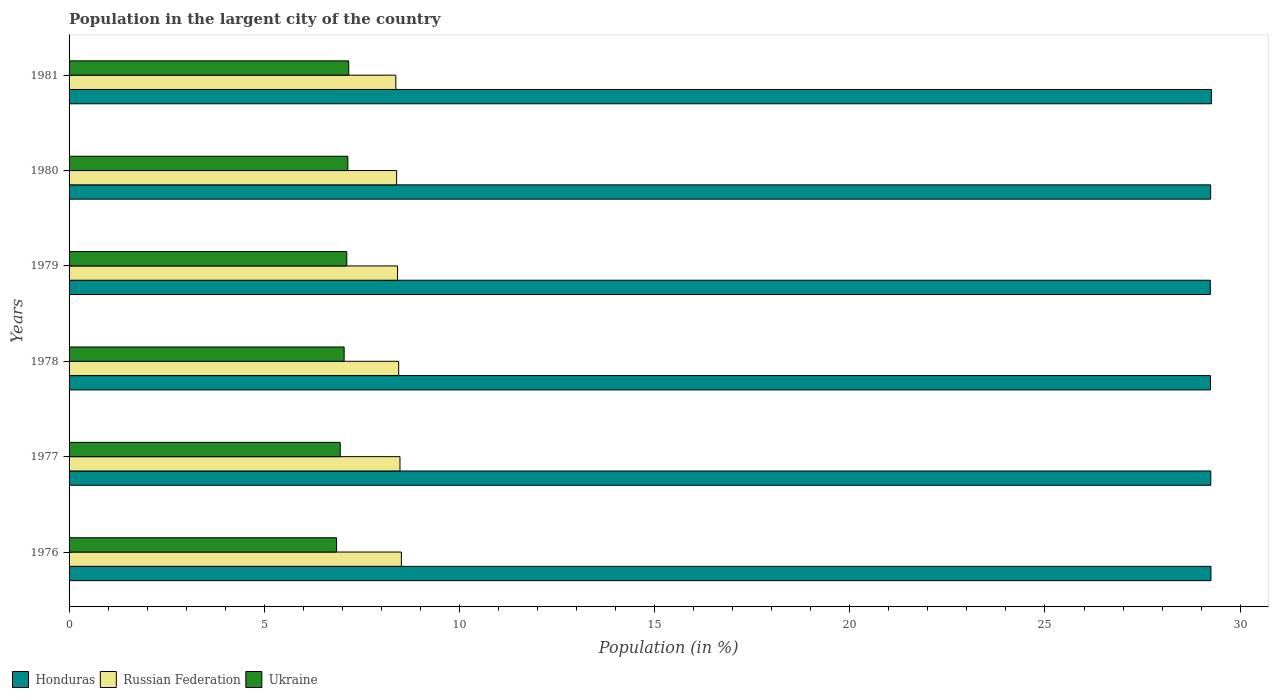Are the number of bars per tick equal to the number of legend labels?
Offer a terse response. Yes. In how many cases, is the number of bars for a given year not equal to the number of legend labels?
Your answer should be compact. 0. What is the percentage of population in the largent city in Honduras in 1976?
Keep it short and to the point. 29.25. Across all years, what is the maximum percentage of population in the largent city in Ukraine?
Ensure brevity in your answer.  7.16. Across all years, what is the minimum percentage of population in the largent city in Honduras?
Your answer should be compact. 29.24. In which year was the percentage of population in the largent city in Russian Federation maximum?
Make the answer very short. 1976. What is the total percentage of population in the largent city in Honduras in the graph?
Your answer should be very brief. 175.48. What is the difference between the percentage of population in the largent city in Russian Federation in 1976 and that in 1977?
Ensure brevity in your answer.  0.04. What is the difference between the percentage of population in the largent city in Honduras in 1981 and the percentage of population in the largent city in Ukraine in 1976?
Offer a terse response. 22.41. What is the average percentage of population in the largent city in Russian Federation per year?
Your answer should be very brief. 8.44. In the year 1979, what is the difference between the percentage of population in the largent city in Honduras and percentage of population in the largent city in Russian Federation?
Provide a succinct answer. 20.82. In how many years, is the percentage of population in the largent city in Ukraine greater than 13 %?
Make the answer very short. 0. What is the ratio of the percentage of population in the largent city in Ukraine in 1977 to that in 1978?
Your answer should be compact. 0.99. Is the percentage of population in the largent city in Ukraine in 1977 less than that in 1980?
Make the answer very short. Yes. Is the difference between the percentage of population in the largent city in Honduras in 1976 and 1979 greater than the difference between the percentage of population in the largent city in Russian Federation in 1976 and 1979?
Your response must be concise. No. What is the difference between the highest and the second highest percentage of population in the largent city in Honduras?
Your response must be concise. 0.01. What is the difference between the highest and the lowest percentage of population in the largent city in Ukraine?
Provide a short and direct response. 0.31. In how many years, is the percentage of population in the largent city in Russian Federation greater than the average percentage of population in the largent city in Russian Federation taken over all years?
Give a very brief answer. 3. Is the sum of the percentage of population in the largent city in Ukraine in 1976 and 1978 greater than the maximum percentage of population in the largent city in Honduras across all years?
Offer a terse response. No. What does the 3rd bar from the top in 1976 represents?
Your answer should be very brief. Honduras. What does the 2nd bar from the bottom in 1981 represents?
Make the answer very short. Russian Federation. How many years are there in the graph?
Give a very brief answer. 6. Does the graph contain any zero values?
Your answer should be compact. No. How are the legend labels stacked?
Your response must be concise. Horizontal. What is the title of the graph?
Provide a short and direct response. Population in the largent city of the country. Does "Low & middle income" appear as one of the legend labels in the graph?
Offer a very short reply. No. What is the label or title of the X-axis?
Offer a very short reply. Population (in %). What is the label or title of the Y-axis?
Give a very brief answer. Years. What is the Population (in %) of Honduras in 1976?
Your response must be concise. 29.25. What is the Population (in %) in Russian Federation in 1976?
Ensure brevity in your answer.  8.51. What is the Population (in %) of Ukraine in 1976?
Make the answer very short. 6.85. What is the Population (in %) in Honduras in 1977?
Offer a very short reply. 29.25. What is the Population (in %) in Russian Federation in 1977?
Provide a short and direct response. 8.48. What is the Population (in %) of Ukraine in 1977?
Provide a succinct answer. 6.95. What is the Population (in %) of Honduras in 1978?
Make the answer very short. 29.24. What is the Population (in %) of Russian Federation in 1978?
Provide a succinct answer. 8.44. What is the Population (in %) of Ukraine in 1978?
Make the answer very short. 7.05. What is the Population (in %) in Honduras in 1979?
Give a very brief answer. 29.24. What is the Population (in %) of Russian Federation in 1979?
Keep it short and to the point. 8.42. What is the Population (in %) of Ukraine in 1979?
Give a very brief answer. 7.11. What is the Population (in %) of Honduras in 1980?
Provide a short and direct response. 29.24. What is the Population (in %) in Russian Federation in 1980?
Keep it short and to the point. 8.39. What is the Population (in %) in Ukraine in 1980?
Your response must be concise. 7.14. What is the Population (in %) in Honduras in 1981?
Provide a short and direct response. 29.26. What is the Population (in %) of Russian Federation in 1981?
Provide a short and direct response. 8.37. What is the Population (in %) of Ukraine in 1981?
Keep it short and to the point. 7.16. Across all years, what is the maximum Population (in %) of Honduras?
Provide a short and direct response. 29.26. Across all years, what is the maximum Population (in %) in Russian Federation?
Offer a terse response. 8.51. Across all years, what is the maximum Population (in %) in Ukraine?
Provide a succinct answer. 7.16. Across all years, what is the minimum Population (in %) in Honduras?
Ensure brevity in your answer.  29.24. Across all years, what is the minimum Population (in %) in Russian Federation?
Make the answer very short. 8.37. Across all years, what is the minimum Population (in %) in Ukraine?
Provide a succinct answer. 6.85. What is the total Population (in %) of Honduras in the graph?
Offer a very short reply. 175.48. What is the total Population (in %) in Russian Federation in the graph?
Give a very brief answer. 50.61. What is the total Population (in %) of Ukraine in the graph?
Provide a succinct answer. 42.26. What is the difference between the Population (in %) of Honduras in 1976 and that in 1977?
Make the answer very short. 0. What is the difference between the Population (in %) of Russian Federation in 1976 and that in 1977?
Make the answer very short. 0.04. What is the difference between the Population (in %) of Ukraine in 1976 and that in 1977?
Ensure brevity in your answer.  -0.09. What is the difference between the Population (in %) in Honduras in 1976 and that in 1978?
Offer a very short reply. 0.01. What is the difference between the Population (in %) of Russian Federation in 1976 and that in 1978?
Make the answer very short. 0.07. What is the difference between the Population (in %) of Ukraine in 1976 and that in 1978?
Make the answer very short. -0.19. What is the difference between the Population (in %) of Honduras in 1976 and that in 1979?
Make the answer very short. 0.02. What is the difference between the Population (in %) of Russian Federation in 1976 and that in 1979?
Your response must be concise. 0.1. What is the difference between the Population (in %) of Ukraine in 1976 and that in 1979?
Your response must be concise. -0.26. What is the difference between the Population (in %) of Honduras in 1976 and that in 1980?
Keep it short and to the point. 0.01. What is the difference between the Population (in %) in Russian Federation in 1976 and that in 1980?
Keep it short and to the point. 0.12. What is the difference between the Population (in %) of Ukraine in 1976 and that in 1980?
Your response must be concise. -0.29. What is the difference between the Population (in %) in Honduras in 1976 and that in 1981?
Ensure brevity in your answer.  -0.01. What is the difference between the Population (in %) in Russian Federation in 1976 and that in 1981?
Provide a short and direct response. 0.14. What is the difference between the Population (in %) of Ukraine in 1976 and that in 1981?
Your answer should be very brief. -0.31. What is the difference between the Population (in %) in Honduras in 1977 and that in 1978?
Your response must be concise. 0.01. What is the difference between the Population (in %) of Russian Federation in 1977 and that in 1978?
Keep it short and to the point. 0.03. What is the difference between the Population (in %) in Ukraine in 1977 and that in 1978?
Ensure brevity in your answer.  -0.1. What is the difference between the Population (in %) of Honduras in 1977 and that in 1979?
Your response must be concise. 0.01. What is the difference between the Population (in %) in Russian Federation in 1977 and that in 1979?
Provide a short and direct response. 0.06. What is the difference between the Population (in %) of Ukraine in 1977 and that in 1979?
Offer a terse response. -0.17. What is the difference between the Population (in %) in Honduras in 1977 and that in 1980?
Your response must be concise. 0. What is the difference between the Population (in %) in Russian Federation in 1977 and that in 1980?
Your answer should be very brief. 0.09. What is the difference between the Population (in %) of Ukraine in 1977 and that in 1980?
Provide a succinct answer. -0.19. What is the difference between the Population (in %) of Honduras in 1977 and that in 1981?
Your answer should be very brief. -0.02. What is the difference between the Population (in %) of Russian Federation in 1977 and that in 1981?
Your response must be concise. 0.11. What is the difference between the Population (in %) of Ukraine in 1977 and that in 1981?
Your answer should be compact. -0.22. What is the difference between the Population (in %) in Honduras in 1978 and that in 1979?
Offer a terse response. 0. What is the difference between the Population (in %) of Russian Federation in 1978 and that in 1979?
Your response must be concise. 0.03. What is the difference between the Population (in %) of Ukraine in 1978 and that in 1979?
Your answer should be compact. -0.07. What is the difference between the Population (in %) in Honduras in 1978 and that in 1980?
Give a very brief answer. -0. What is the difference between the Population (in %) of Russian Federation in 1978 and that in 1980?
Give a very brief answer. 0.05. What is the difference between the Population (in %) in Ukraine in 1978 and that in 1980?
Provide a short and direct response. -0.09. What is the difference between the Population (in %) in Honduras in 1978 and that in 1981?
Offer a terse response. -0.02. What is the difference between the Population (in %) of Russian Federation in 1978 and that in 1981?
Offer a very short reply. 0.07. What is the difference between the Population (in %) of Ukraine in 1978 and that in 1981?
Offer a terse response. -0.12. What is the difference between the Population (in %) in Honduras in 1979 and that in 1980?
Your answer should be compact. -0.01. What is the difference between the Population (in %) of Russian Federation in 1979 and that in 1980?
Make the answer very short. 0.02. What is the difference between the Population (in %) of Ukraine in 1979 and that in 1980?
Ensure brevity in your answer.  -0.03. What is the difference between the Population (in %) in Honduras in 1979 and that in 1981?
Keep it short and to the point. -0.03. What is the difference between the Population (in %) in Russian Federation in 1979 and that in 1981?
Offer a terse response. 0.04. What is the difference between the Population (in %) of Ukraine in 1979 and that in 1981?
Keep it short and to the point. -0.05. What is the difference between the Population (in %) of Honduras in 1980 and that in 1981?
Offer a terse response. -0.02. What is the difference between the Population (in %) of Russian Federation in 1980 and that in 1981?
Provide a short and direct response. 0.02. What is the difference between the Population (in %) in Ukraine in 1980 and that in 1981?
Offer a very short reply. -0.02. What is the difference between the Population (in %) in Honduras in 1976 and the Population (in %) in Russian Federation in 1977?
Offer a very short reply. 20.77. What is the difference between the Population (in %) of Honduras in 1976 and the Population (in %) of Ukraine in 1977?
Your answer should be compact. 22.31. What is the difference between the Population (in %) in Russian Federation in 1976 and the Population (in %) in Ukraine in 1977?
Provide a short and direct response. 1.57. What is the difference between the Population (in %) of Honduras in 1976 and the Population (in %) of Russian Federation in 1978?
Give a very brief answer. 20.81. What is the difference between the Population (in %) of Honduras in 1976 and the Population (in %) of Ukraine in 1978?
Give a very brief answer. 22.21. What is the difference between the Population (in %) in Russian Federation in 1976 and the Population (in %) in Ukraine in 1978?
Offer a very short reply. 1.47. What is the difference between the Population (in %) in Honduras in 1976 and the Population (in %) in Russian Federation in 1979?
Your answer should be very brief. 20.84. What is the difference between the Population (in %) in Honduras in 1976 and the Population (in %) in Ukraine in 1979?
Give a very brief answer. 22.14. What is the difference between the Population (in %) of Russian Federation in 1976 and the Population (in %) of Ukraine in 1979?
Offer a very short reply. 1.4. What is the difference between the Population (in %) in Honduras in 1976 and the Population (in %) in Russian Federation in 1980?
Provide a succinct answer. 20.86. What is the difference between the Population (in %) of Honduras in 1976 and the Population (in %) of Ukraine in 1980?
Provide a succinct answer. 22.11. What is the difference between the Population (in %) of Russian Federation in 1976 and the Population (in %) of Ukraine in 1980?
Provide a short and direct response. 1.37. What is the difference between the Population (in %) of Honduras in 1976 and the Population (in %) of Russian Federation in 1981?
Make the answer very short. 20.88. What is the difference between the Population (in %) of Honduras in 1976 and the Population (in %) of Ukraine in 1981?
Your response must be concise. 22.09. What is the difference between the Population (in %) in Russian Federation in 1976 and the Population (in %) in Ukraine in 1981?
Your answer should be very brief. 1.35. What is the difference between the Population (in %) in Honduras in 1977 and the Population (in %) in Russian Federation in 1978?
Give a very brief answer. 20.8. What is the difference between the Population (in %) of Honduras in 1977 and the Population (in %) of Ukraine in 1978?
Your answer should be very brief. 22.2. What is the difference between the Population (in %) in Russian Federation in 1977 and the Population (in %) in Ukraine in 1978?
Keep it short and to the point. 1.43. What is the difference between the Population (in %) of Honduras in 1977 and the Population (in %) of Russian Federation in 1979?
Your response must be concise. 20.83. What is the difference between the Population (in %) of Honduras in 1977 and the Population (in %) of Ukraine in 1979?
Give a very brief answer. 22.13. What is the difference between the Population (in %) in Russian Federation in 1977 and the Population (in %) in Ukraine in 1979?
Your answer should be very brief. 1.36. What is the difference between the Population (in %) in Honduras in 1977 and the Population (in %) in Russian Federation in 1980?
Provide a succinct answer. 20.86. What is the difference between the Population (in %) of Honduras in 1977 and the Population (in %) of Ukraine in 1980?
Offer a very short reply. 22.11. What is the difference between the Population (in %) of Russian Federation in 1977 and the Population (in %) of Ukraine in 1980?
Your answer should be compact. 1.34. What is the difference between the Population (in %) of Honduras in 1977 and the Population (in %) of Russian Federation in 1981?
Ensure brevity in your answer.  20.88. What is the difference between the Population (in %) in Honduras in 1977 and the Population (in %) in Ukraine in 1981?
Give a very brief answer. 22.08. What is the difference between the Population (in %) in Russian Federation in 1977 and the Population (in %) in Ukraine in 1981?
Offer a very short reply. 1.31. What is the difference between the Population (in %) of Honduras in 1978 and the Population (in %) of Russian Federation in 1979?
Offer a very short reply. 20.82. What is the difference between the Population (in %) of Honduras in 1978 and the Population (in %) of Ukraine in 1979?
Your answer should be compact. 22.13. What is the difference between the Population (in %) of Russian Federation in 1978 and the Population (in %) of Ukraine in 1979?
Provide a succinct answer. 1.33. What is the difference between the Population (in %) of Honduras in 1978 and the Population (in %) of Russian Federation in 1980?
Offer a terse response. 20.85. What is the difference between the Population (in %) of Honduras in 1978 and the Population (in %) of Ukraine in 1980?
Keep it short and to the point. 22.1. What is the difference between the Population (in %) in Russian Federation in 1978 and the Population (in %) in Ukraine in 1980?
Provide a succinct answer. 1.3. What is the difference between the Population (in %) in Honduras in 1978 and the Population (in %) in Russian Federation in 1981?
Your response must be concise. 20.87. What is the difference between the Population (in %) in Honduras in 1978 and the Population (in %) in Ukraine in 1981?
Keep it short and to the point. 22.08. What is the difference between the Population (in %) in Russian Federation in 1978 and the Population (in %) in Ukraine in 1981?
Keep it short and to the point. 1.28. What is the difference between the Population (in %) of Honduras in 1979 and the Population (in %) of Russian Federation in 1980?
Offer a very short reply. 20.84. What is the difference between the Population (in %) of Honduras in 1979 and the Population (in %) of Ukraine in 1980?
Provide a succinct answer. 22.09. What is the difference between the Population (in %) in Russian Federation in 1979 and the Population (in %) in Ukraine in 1980?
Your answer should be very brief. 1.27. What is the difference between the Population (in %) of Honduras in 1979 and the Population (in %) of Russian Federation in 1981?
Ensure brevity in your answer.  20.86. What is the difference between the Population (in %) in Honduras in 1979 and the Population (in %) in Ukraine in 1981?
Your answer should be compact. 22.07. What is the difference between the Population (in %) of Russian Federation in 1979 and the Population (in %) of Ukraine in 1981?
Offer a terse response. 1.25. What is the difference between the Population (in %) in Honduras in 1980 and the Population (in %) in Russian Federation in 1981?
Ensure brevity in your answer.  20.87. What is the difference between the Population (in %) of Honduras in 1980 and the Population (in %) of Ukraine in 1981?
Your answer should be very brief. 22.08. What is the difference between the Population (in %) in Russian Federation in 1980 and the Population (in %) in Ukraine in 1981?
Make the answer very short. 1.23. What is the average Population (in %) in Honduras per year?
Give a very brief answer. 29.25. What is the average Population (in %) of Russian Federation per year?
Provide a short and direct response. 8.44. What is the average Population (in %) in Ukraine per year?
Offer a very short reply. 7.04. In the year 1976, what is the difference between the Population (in %) in Honduras and Population (in %) in Russian Federation?
Make the answer very short. 20.74. In the year 1976, what is the difference between the Population (in %) in Honduras and Population (in %) in Ukraine?
Your answer should be very brief. 22.4. In the year 1976, what is the difference between the Population (in %) in Russian Federation and Population (in %) in Ukraine?
Provide a short and direct response. 1.66. In the year 1977, what is the difference between the Population (in %) in Honduras and Population (in %) in Russian Federation?
Offer a very short reply. 20.77. In the year 1977, what is the difference between the Population (in %) in Honduras and Population (in %) in Ukraine?
Ensure brevity in your answer.  22.3. In the year 1977, what is the difference between the Population (in %) in Russian Federation and Population (in %) in Ukraine?
Offer a very short reply. 1.53. In the year 1978, what is the difference between the Population (in %) in Honduras and Population (in %) in Russian Federation?
Make the answer very short. 20.8. In the year 1978, what is the difference between the Population (in %) in Honduras and Population (in %) in Ukraine?
Ensure brevity in your answer.  22.19. In the year 1978, what is the difference between the Population (in %) of Russian Federation and Population (in %) of Ukraine?
Provide a short and direct response. 1.4. In the year 1979, what is the difference between the Population (in %) of Honduras and Population (in %) of Russian Federation?
Provide a short and direct response. 20.82. In the year 1979, what is the difference between the Population (in %) in Honduras and Population (in %) in Ukraine?
Ensure brevity in your answer.  22.12. In the year 1979, what is the difference between the Population (in %) in Russian Federation and Population (in %) in Ukraine?
Keep it short and to the point. 1.3. In the year 1980, what is the difference between the Population (in %) of Honduras and Population (in %) of Russian Federation?
Give a very brief answer. 20.85. In the year 1980, what is the difference between the Population (in %) of Honduras and Population (in %) of Ukraine?
Ensure brevity in your answer.  22.1. In the year 1980, what is the difference between the Population (in %) of Russian Federation and Population (in %) of Ukraine?
Ensure brevity in your answer.  1.25. In the year 1981, what is the difference between the Population (in %) in Honduras and Population (in %) in Russian Federation?
Ensure brevity in your answer.  20.89. In the year 1981, what is the difference between the Population (in %) in Honduras and Population (in %) in Ukraine?
Keep it short and to the point. 22.1. In the year 1981, what is the difference between the Population (in %) in Russian Federation and Population (in %) in Ukraine?
Provide a short and direct response. 1.21. What is the ratio of the Population (in %) of Russian Federation in 1976 to that in 1977?
Ensure brevity in your answer.  1. What is the ratio of the Population (in %) of Ukraine in 1976 to that in 1977?
Your answer should be compact. 0.99. What is the ratio of the Population (in %) in Honduras in 1976 to that in 1978?
Your answer should be compact. 1. What is the ratio of the Population (in %) in Russian Federation in 1976 to that in 1978?
Give a very brief answer. 1.01. What is the ratio of the Population (in %) of Ukraine in 1976 to that in 1978?
Give a very brief answer. 0.97. What is the ratio of the Population (in %) in Honduras in 1976 to that in 1979?
Your answer should be very brief. 1. What is the ratio of the Population (in %) in Russian Federation in 1976 to that in 1979?
Give a very brief answer. 1.01. What is the ratio of the Population (in %) in Ukraine in 1976 to that in 1979?
Give a very brief answer. 0.96. What is the ratio of the Population (in %) of Russian Federation in 1976 to that in 1980?
Keep it short and to the point. 1.01. What is the ratio of the Population (in %) of Ukraine in 1976 to that in 1980?
Keep it short and to the point. 0.96. What is the ratio of the Population (in %) in Russian Federation in 1976 to that in 1981?
Your answer should be compact. 1.02. What is the ratio of the Population (in %) of Ukraine in 1976 to that in 1981?
Ensure brevity in your answer.  0.96. What is the ratio of the Population (in %) of Honduras in 1977 to that in 1978?
Provide a short and direct response. 1. What is the ratio of the Population (in %) in Ukraine in 1977 to that in 1978?
Your response must be concise. 0.99. What is the ratio of the Population (in %) in Honduras in 1977 to that in 1979?
Your answer should be very brief. 1. What is the ratio of the Population (in %) in Russian Federation in 1977 to that in 1979?
Ensure brevity in your answer.  1.01. What is the ratio of the Population (in %) of Ukraine in 1977 to that in 1979?
Give a very brief answer. 0.98. What is the ratio of the Population (in %) in Russian Federation in 1977 to that in 1980?
Offer a very short reply. 1.01. What is the ratio of the Population (in %) of Ukraine in 1977 to that in 1980?
Give a very brief answer. 0.97. What is the ratio of the Population (in %) in Honduras in 1977 to that in 1981?
Your answer should be compact. 1. What is the ratio of the Population (in %) in Russian Federation in 1977 to that in 1981?
Provide a short and direct response. 1.01. What is the ratio of the Population (in %) of Ukraine in 1977 to that in 1981?
Ensure brevity in your answer.  0.97. What is the ratio of the Population (in %) of Honduras in 1978 to that in 1980?
Your answer should be very brief. 1. What is the ratio of the Population (in %) in Ukraine in 1978 to that in 1980?
Your response must be concise. 0.99. What is the ratio of the Population (in %) of Russian Federation in 1978 to that in 1981?
Offer a very short reply. 1.01. What is the ratio of the Population (in %) of Ukraine in 1978 to that in 1981?
Give a very brief answer. 0.98. What is the ratio of the Population (in %) in Russian Federation in 1979 to that in 1980?
Give a very brief answer. 1. What is the ratio of the Population (in %) in Ukraine in 1979 to that in 1980?
Provide a succinct answer. 1. What is the difference between the highest and the second highest Population (in %) of Honduras?
Ensure brevity in your answer.  0.01. What is the difference between the highest and the second highest Population (in %) in Russian Federation?
Give a very brief answer. 0.04. What is the difference between the highest and the second highest Population (in %) of Ukraine?
Your answer should be compact. 0.02. What is the difference between the highest and the lowest Population (in %) of Honduras?
Give a very brief answer. 0.03. What is the difference between the highest and the lowest Population (in %) in Russian Federation?
Provide a succinct answer. 0.14. What is the difference between the highest and the lowest Population (in %) of Ukraine?
Your response must be concise. 0.31. 